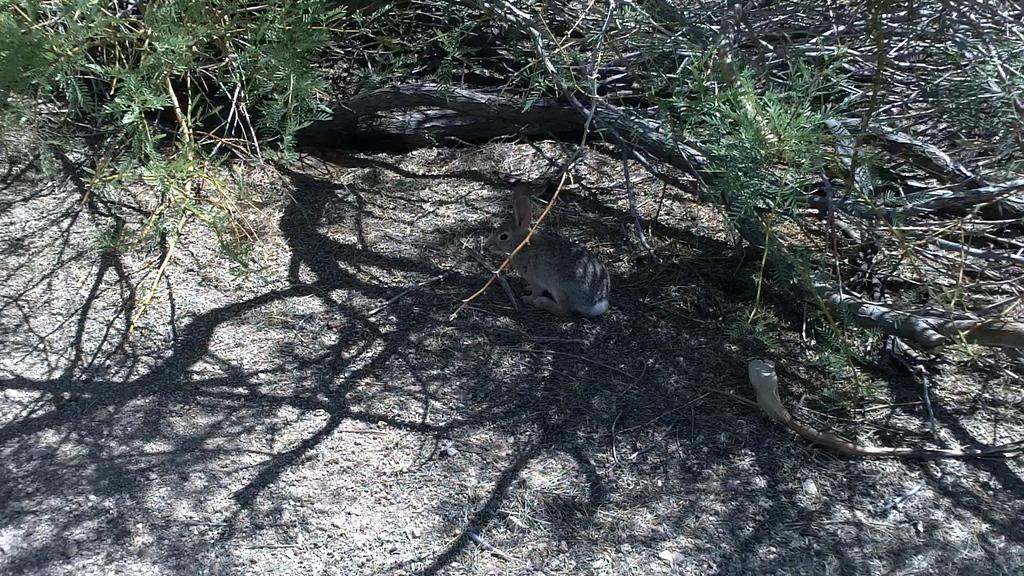Describe this image in one or two sentences. In this image we can see a rabbit. Also we can see branches of trees with leaves. 